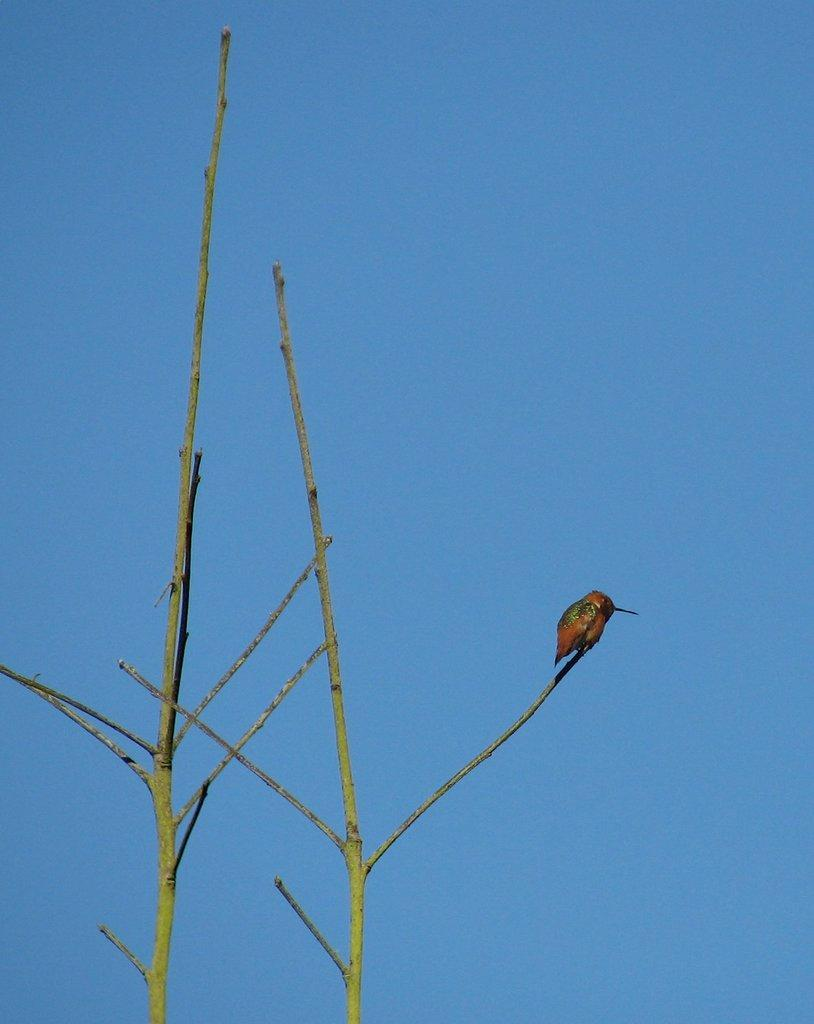What type of animal can be seen in the image? There is a bird in the image. Where is the bird located? The bird is on a plant stem. What can be seen in the background of the image? There is sky visible in the background of the image. What type of glue is the bird using to stick itself to the plant stem? There is no glue present in the image, and the bird is not using any glue to stick itself to the plant stem. 